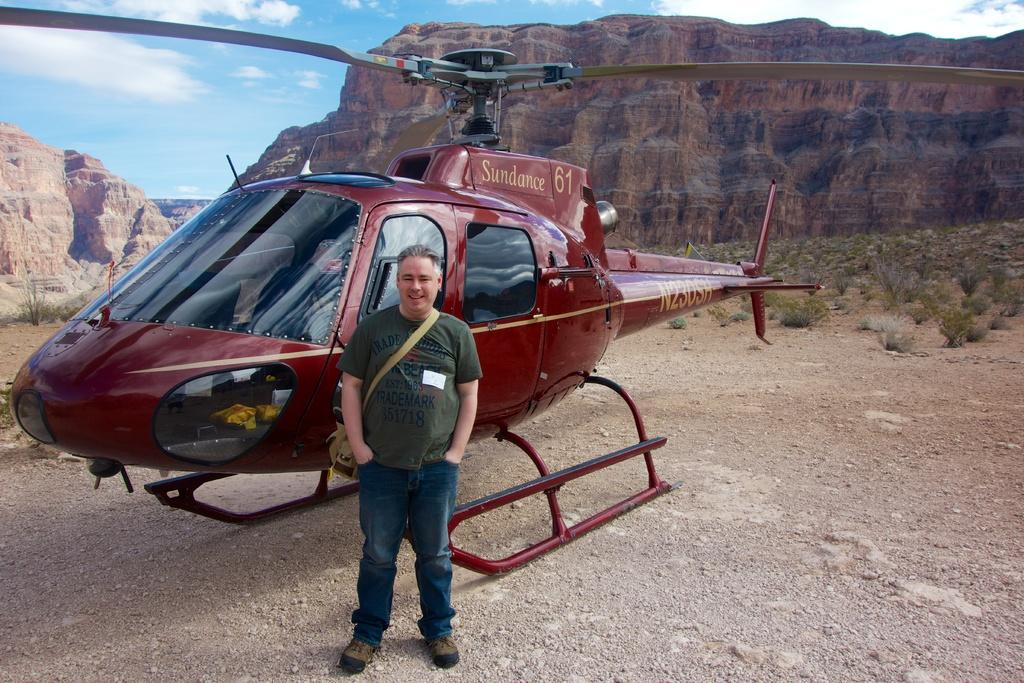What is the main subject of the image? The main subject of the image is a helicopter. Can you describe the person in the image? There is a man standing in front of the helicopter. What can be seen in the background of the image? There are mountains and the sky visible in the background of the image. What type of terrain is present in the image? There is grass on the ground in the image. How many cacti are growing near the helicopter in the image? There are no cacti present in the image; the ground is covered with grass. What type of wing is visible on the helicopter in the image? The helicopter in the image has rotor blades, not wings, as it is a rotary-wing aircraft. 